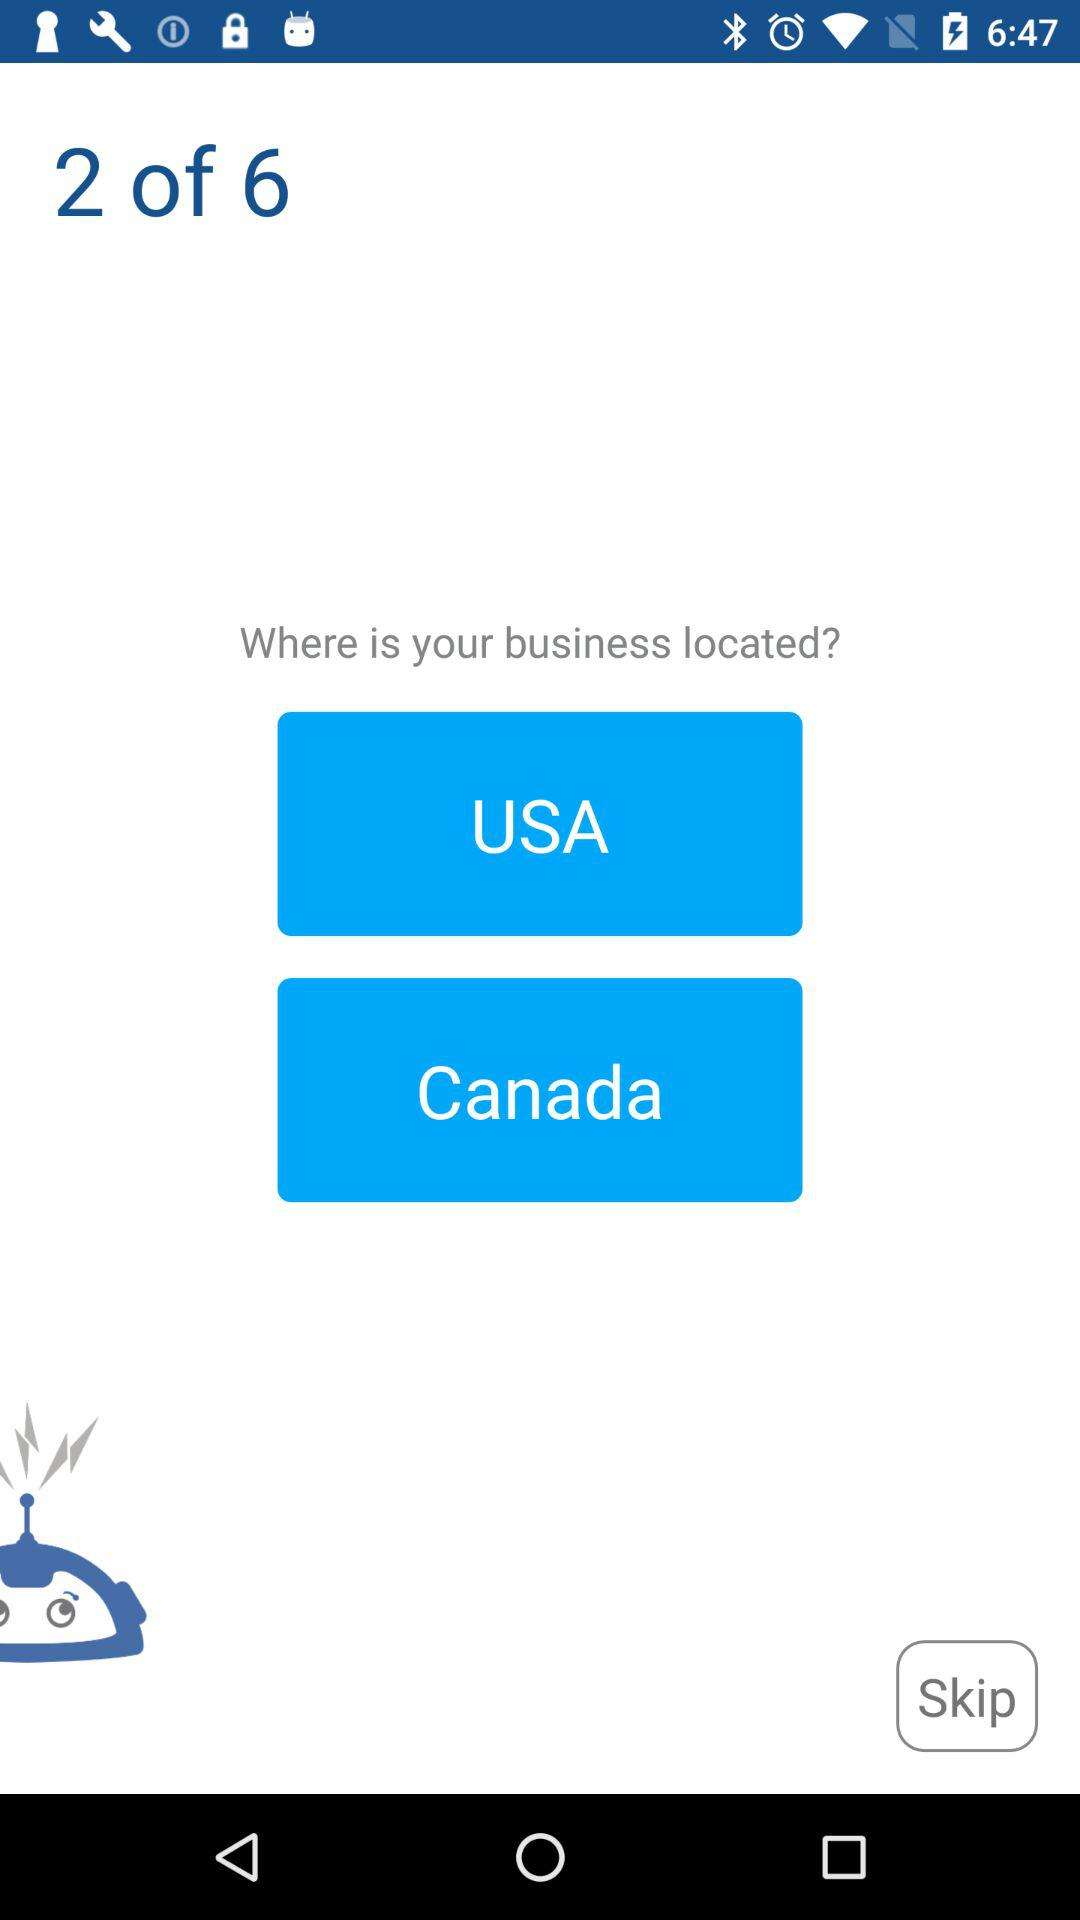How many questions in total are there? In total, there are 6 questions. 